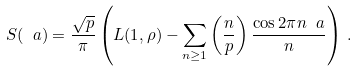<formula> <loc_0><loc_0><loc_500><loc_500>S ( \ a ) = \frac { \sqrt { p } } { \pi } \left ( L ( 1 , \rho ) - \sum _ { n \geq 1 } \left ( \frac { n } { p } \right ) \frac { \cos 2 \pi n \ a } { n } \right ) \, .</formula> 